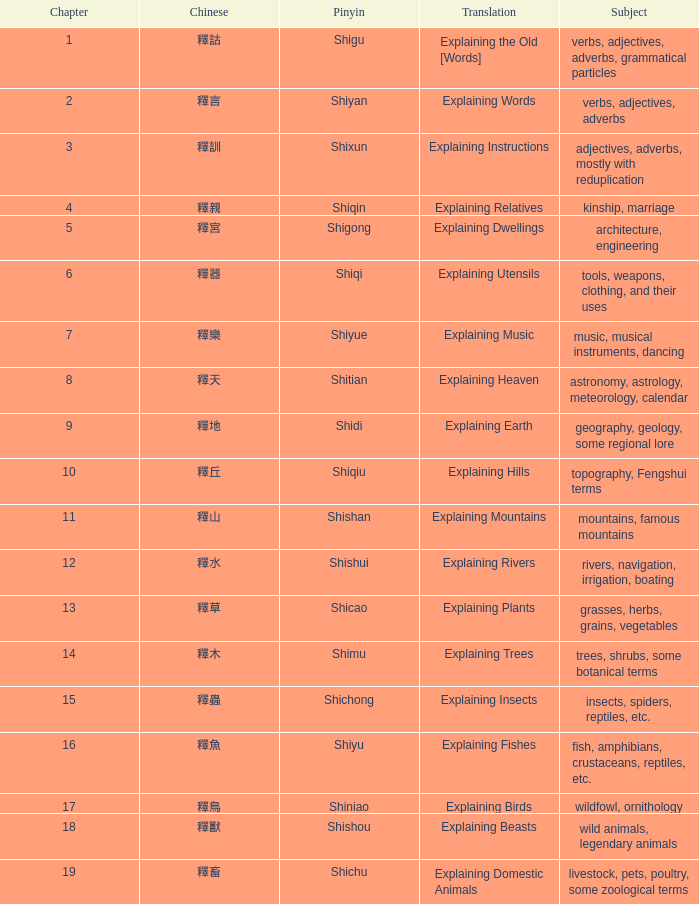Name the chinese with subject of adjectives, adverbs, mostly with reduplication 釋訓. 